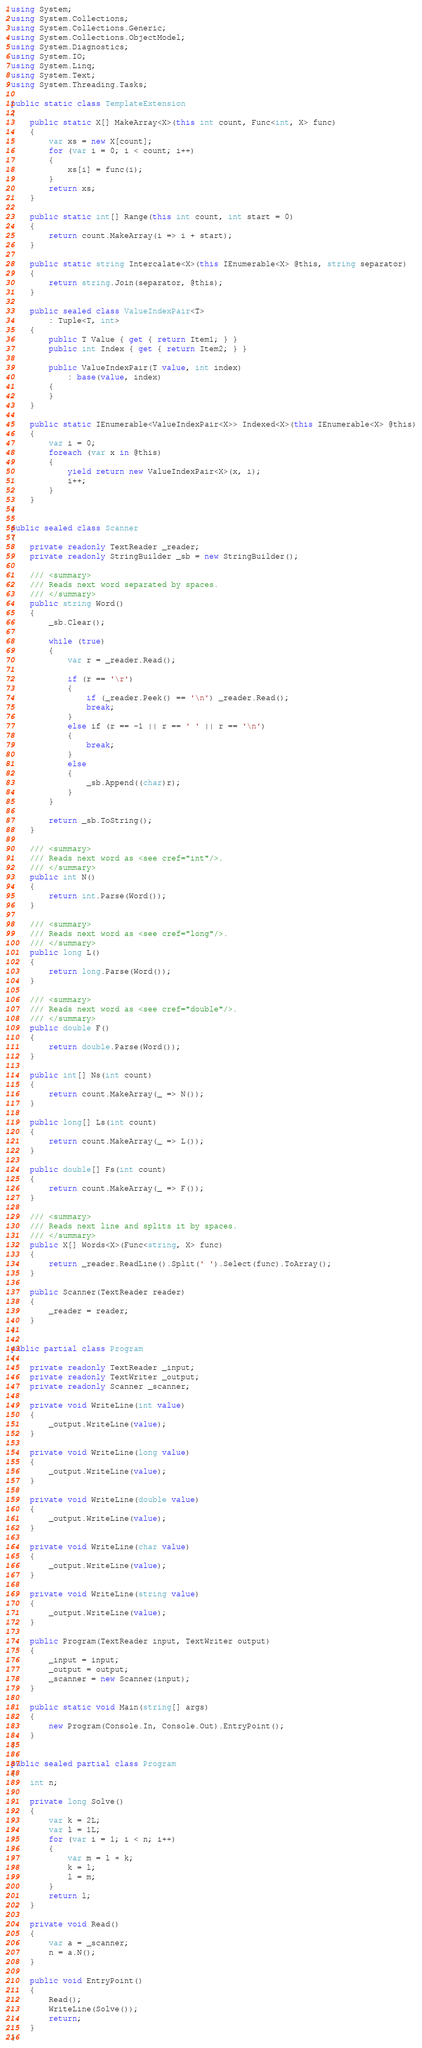<code> <loc_0><loc_0><loc_500><loc_500><_C#_>using System;
using System.Collections;
using System.Collections.Generic;
using System.Collections.ObjectModel;
using System.Diagnostics;
using System.IO;
using System.Linq;
using System.Text;
using System.Threading.Tasks;

public static class TemplateExtension
{
    public static X[] MakeArray<X>(this int count, Func<int, X> func)
    {
        var xs = new X[count];
        for (var i = 0; i < count; i++)
        {
            xs[i] = func(i);
        }
        return xs;
    }

    public static int[] Range(this int count, int start = 0)
    {
        return count.MakeArray(i => i + start);
    }

    public static string Intercalate<X>(this IEnumerable<X> @this, string separator)
    {
        return string.Join(separator, @this);
    }

    public sealed class ValueIndexPair<T>
        : Tuple<T, int>
    {
        public T Value { get { return Item1; } }
        public int Index { get { return Item2; } }

        public ValueIndexPair(T value, int index)
            : base(value, index)
        {
        }
    }

    public static IEnumerable<ValueIndexPair<X>> Indexed<X>(this IEnumerable<X> @this)
    {
        var i = 0;
        foreach (var x in @this)
        {
            yield return new ValueIndexPair<X>(x, i);
            i++;
        }
    }
}

public sealed class Scanner
{
    private readonly TextReader _reader;
    private readonly StringBuilder _sb = new StringBuilder();

    /// <summary>
    /// Reads next word separated by spaces.
    /// </summary>
    public string Word()
    {
        _sb.Clear();

        while (true)
        {
            var r = _reader.Read();

            if (r == '\r')
            {
                if (_reader.Peek() == '\n') _reader.Read();
                break;
            }
            else if (r == -1 || r == ' ' || r == '\n')
            {
                break;
            }
            else
            {
                _sb.Append((char)r);
            }
        }

        return _sb.ToString();
    }

    /// <summary>
    /// Reads next word as <see cref="int"/>.
    /// </summary>
    public int N()
    {
        return int.Parse(Word());
    }

    /// <summary>
    /// Reads next word as <see cref="long"/>.
    /// </summary>
    public long L()
    {
        return long.Parse(Word());
    }

    /// <summary>
    /// Reads next word as <see cref="double"/>.
    /// </summary>
    public double F()
    {
        return double.Parse(Word());
    }

    public int[] Ns(int count)
    {
        return count.MakeArray(_ => N());
    }

    public long[] Ls(int count)
    {
        return count.MakeArray(_ => L());
    }

    public double[] Fs(int count)
    {
        return count.MakeArray(_ => F());
    }

    /// <summary>
    /// Reads next line and splits it by spaces.
    /// </summary>
    public X[] Words<X>(Func<string, X> func)
    {
        return _reader.ReadLine().Split(' ').Select(func).ToArray();
    }

    public Scanner(TextReader reader)
    {
        _reader = reader;
    }
}

public partial class Program
{
    private readonly TextReader _input;
    private readonly TextWriter _output;
    private readonly Scanner _scanner;

    private void WriteLine(int value)
    {
        _output.WriteLine(value);
    }

    private void WriteLine(long value)
    {
        _output.WriteLine(value);
    }

    private void WriteLine(double value)
    {
        _output.WriteLine(value);
    }

    private void WriteLine(char value)
    {
        _output.WriteLine(value);
    }

    private void WriteLine(string value)
    {
        _output.WriteLine(value);
    }

    public Program(TextReader input, TextWriter output)
    {
        _input = input;
        _output = output;
        _scanner = new Scanner(input);
    }

    public static void Main(string[] args)
    {
        new Program(Console.In, Console.Out).EntryPoint();
    }
}

public sealed partial class Program
{
    int n;

    private long Solve()
    {
        var k = 2L;
        var l = 1L;
        for (var i = 1; i < n; i++)
        {
            var m = l + k;
            k = l;
            l = m;
        }
        return l;
    }

    private void Read()
    {
        var a = _scanner;
        n = a.N();
    }

    public void EntryPoint()
    {
        Read();
        WriteLine(Solve());
        return;
    }
}
</code> 